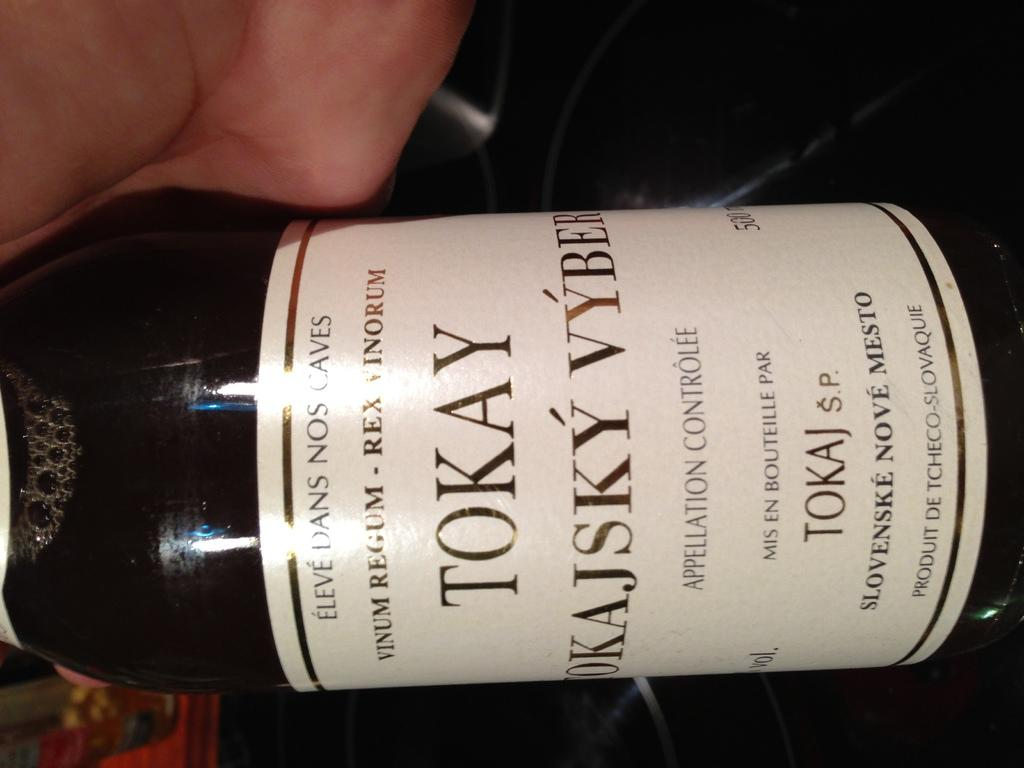What is the main subject of the image? There is a person in the image. What is the person holding in the image? The person is holding a bottle. Can you describe any additional details about the bottle? There is a white color sticker attached to the bottle. What type of berry is the person eating in the image? There is no berry present in the image; the person is holding a bottle with a white color sticker. 